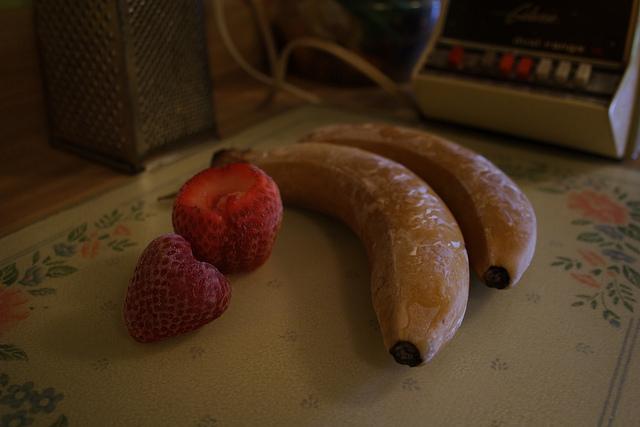Is there a device that can be used to make a smoothie with this fruit?
Quick response, please. Yes. What is the fruit on top of?
Write a very short answer. Placemat. Is the banana whole?
Keep it brief. Yes. What is the red fruit?
Keep it brief. Strawberry. 